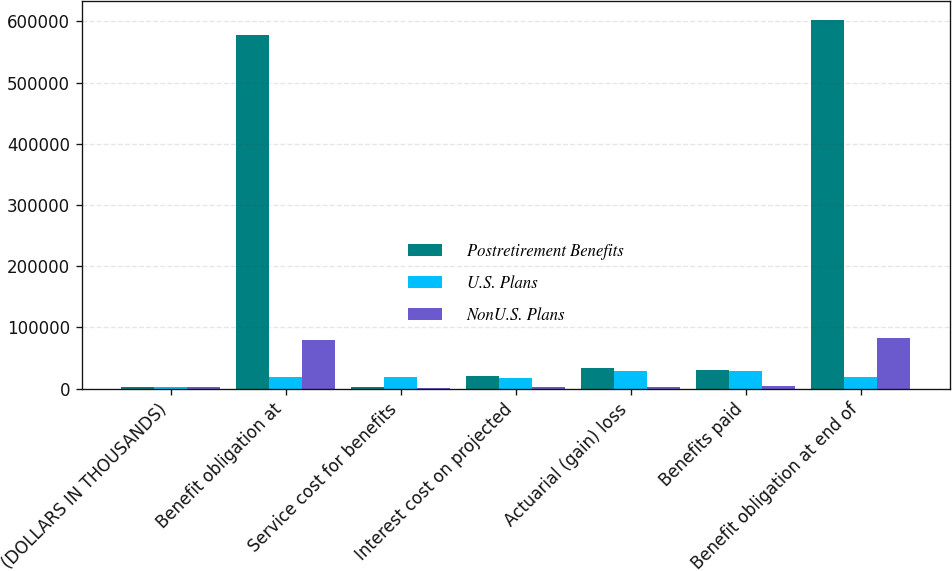Convert chart. <chart><loc_0><loc_0><loc_500><loc_500><stacked_bar_chart><ecel><fcel>(DOLLARS IN THOUSANDS)<fcel>Benefit obligation at<fcel>Service cost for benefits<fcel>Interest cost on projected<fcel>Actuarial (gain) loss<fcel>Benefits paid<fcel>Benefit obligation at end of<nl><fcel>Postretirement Benefits<fcel>2017<fcel>577332<fcel>2175<fcel>20075<fcel>33808<fcel>30700<fcel>602783<nl><fcel>U.S. Plans<fcel>2017<fcel>18652<fcel>18652<fcel>17116<fcel>28552<fcel>28943<fcel>18652<nl><fcel>NonU.S. Plans<fcel>2017<fcel>79845<fcel>718<fcel>2710<fcel>2895<fcel>3911<fcel>82714<nl></chart> 